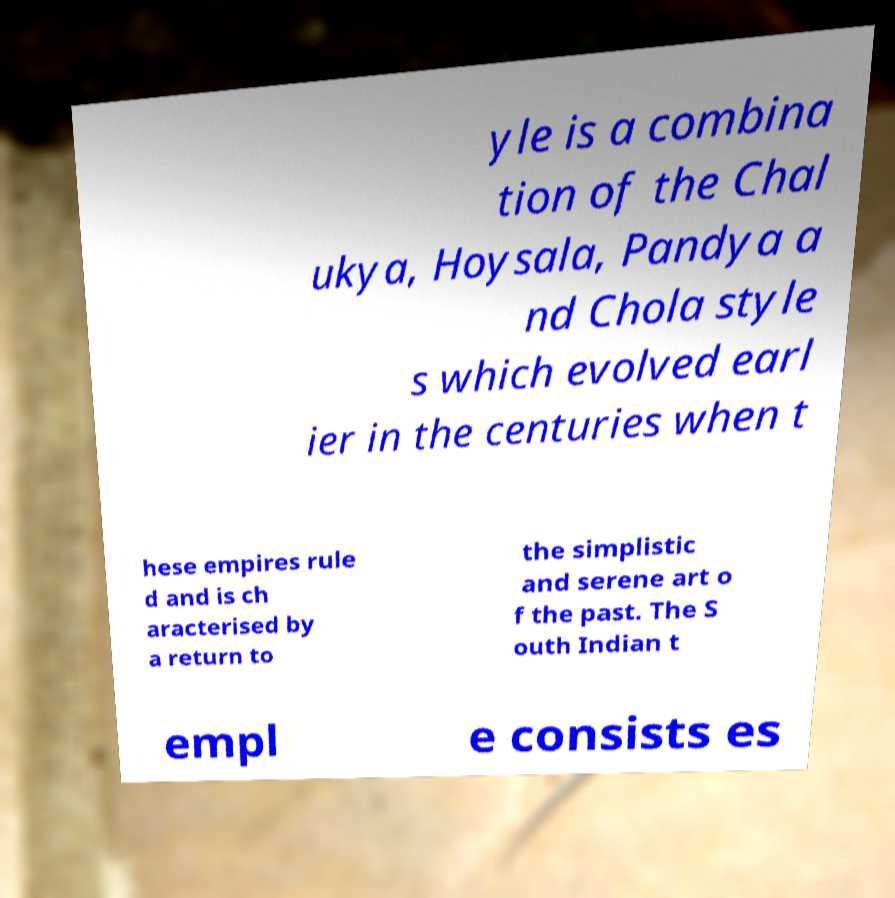Please read and relay the text visible in this image. What does it say? yle is a combina tion of the Chal ukya, Hoysala, Pandya a nd Chola style s which evolved earl ier in the centuries when t hese empires rule d and is ch aracterised by a return to the simplistic and serene art o f the past. The S outh Indian t empl e consists es 